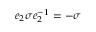Convert formula to latex. <formula><loc_0><loc_0><loc_500><loc_500>e _ { 2 } \sigma e _ { 2 } ^ { - 1 } = - \sigma</formula> 